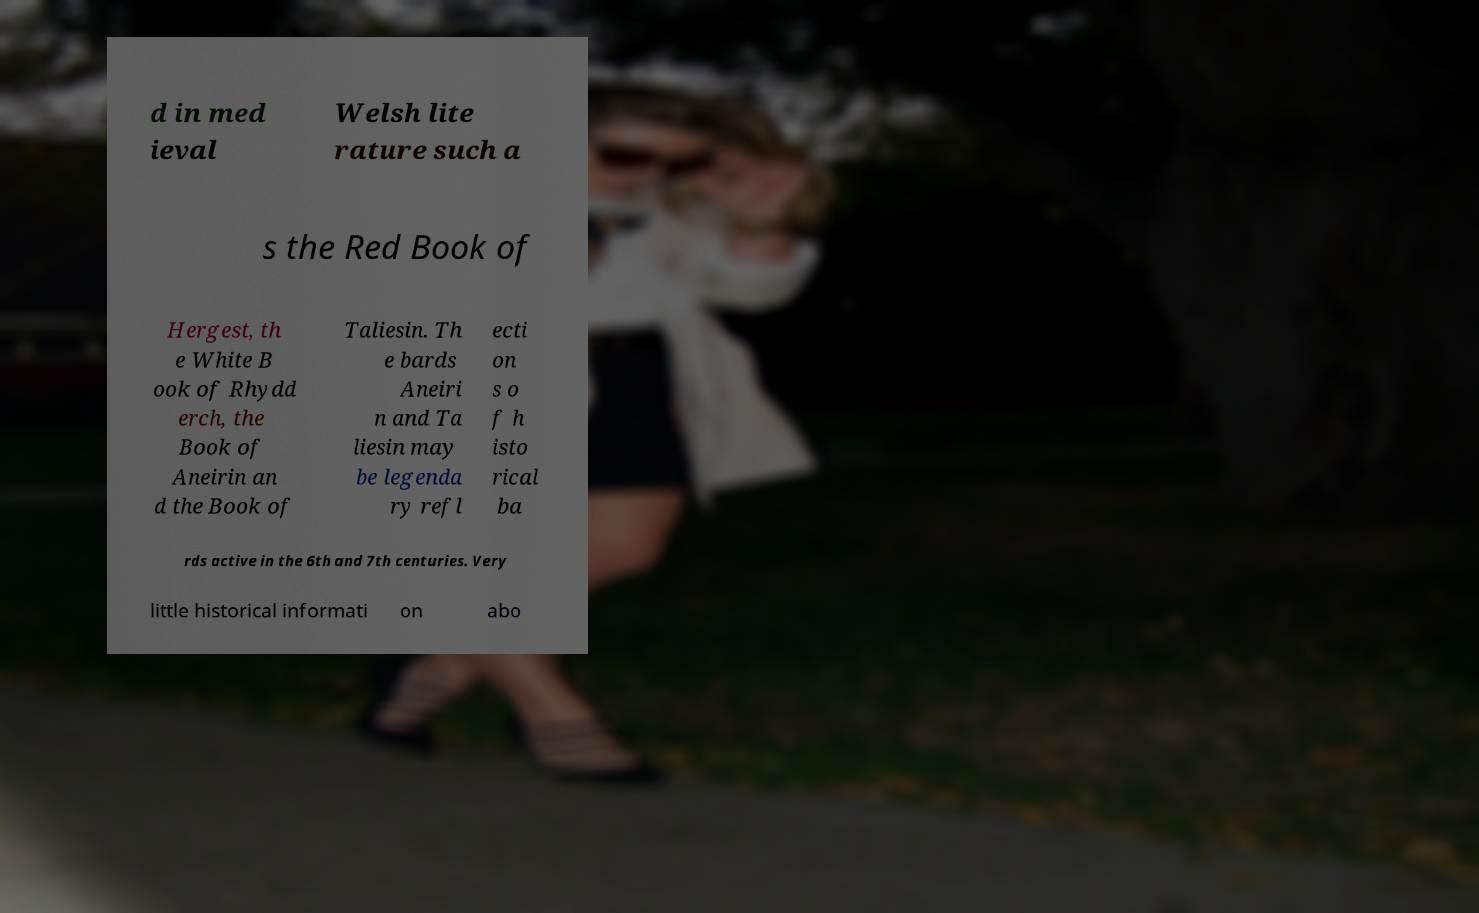Please read and relay the text visible in this image. What does it say? d in med ieval Welsh lite rature such a s the Red Book of Hergest, th e White B ook of Rhydd erch, the Book of Aneirin an d the Book of Taliesin. Th e bards Aneiri n and Ta liesin may be legenda ry refl ecti on s o f h isto rical ba rds active in the 6th and 7th centuries. Very little historical informati on abo 